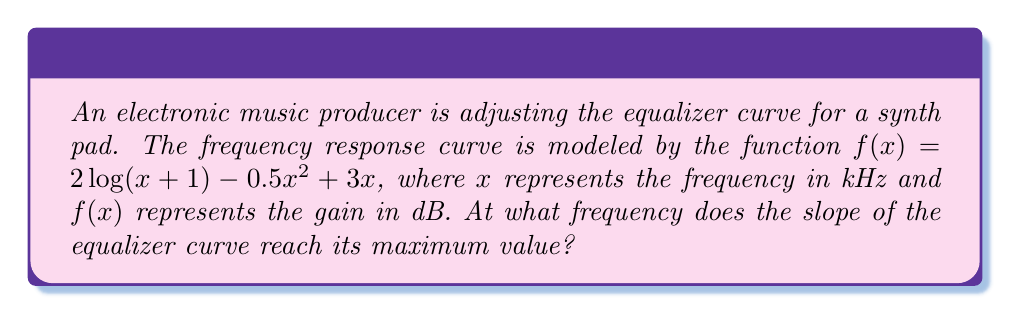Provide a solution to this math problem. To find the frequency where the slope of the equalizer curve reaches its maximum value, we need to follow these steps:

1) First, we need to find the derivative of the function $f(x)$, which represents the slope of the curve:

   $$f'(x) = \frac{2}{x+1} - x + 3$$

2) The maximum slope will occur where the second derivative equals zero. So, let's find the second derivative:

   $$f''(x) = -\frac{2}{(x+1)^2} - 1$$

3) Now, set the second derivative equal to zero and solve for x:

   $$-\frac{2}{(x+1)^2} - 1 = 0$$
   $$-\frac{2}{(x+1)^2} = 1$$
   $$\frac{2}{(x+1)^2} = 1$$
   $$(x+1)^2 = 2$$
   $$x+1 = \sqrt{2}$$
   $$x = \sqrt{2} - 1 \approx 0.414$$

4) To confirm this is a maximum (not a minimum), we can check that $f'''(x)$ is negative at this point:

   $$f'''(x) = \frac{4}{(x+1)^3}$$
   
   At $x = \sqrt{2} - 1$, this is indeed negative.

Therefore, the slope of the equalizer curve reaches its maximum value at approximately 0.414 kHz or 414 Hz.
Answer: $\sqrt{2} - 1$ kHz 